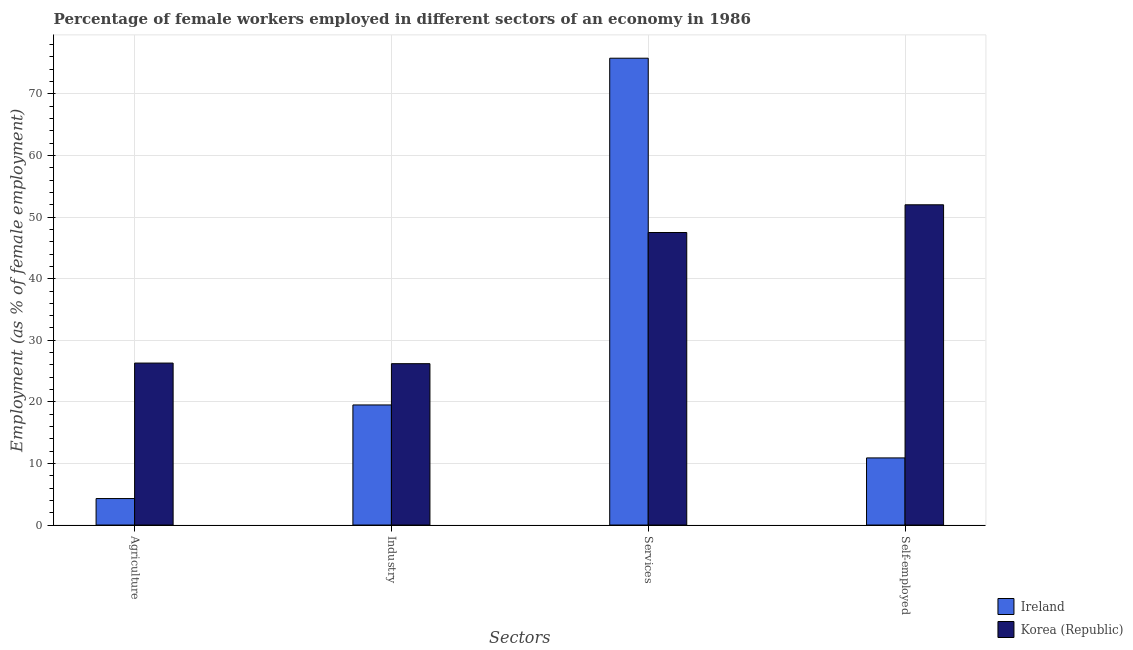Are the number of bars per tick equal to the number of legend labels?
Provide a short and direct response. Yes. Are the number of bars on each tick of the X-axis equal?
Your answer should be very brief. Yes. How many bars are there on the 4th tick from the right?
Your answer should be very brief. 2. What is the label of the 1st group of bars from the left?
Your answer should be compact. Agriculture. What is the percentage of self employed female workers in Ireland?
Your response must be concise. 10.9. Across all countries, what is the maximum percentage of female workers in services?
Give a very brief answer. 75.8. Across all countries, what is the minimum percentage of female workers in services?
Make the answer very short. 47.5. In which country was the percentage of female workers in services maximum?
Ensure brevity in your answer.  Ireland. In which country was the percentage of female workers in agriculture minimum?
Your response must be concise. Ireland. What is the total percentage of female workers in agriculture in the graph?
Your answer should be compact. 30.6. What is the difference between the percentage of female workers in services in Korea (Republic) and that in Ireland?
Offer a terse response. -28.3. What is the difference between the percentage of female workers in services in Ireland and the percentage of self employed female workers in Korea (Republic)?
Your answer should be compact. 23.8. What is the average percentage of self employed female workers per country?
Keep it short and to the point. 31.45. What is the difference between the percentage of female workers in industry and percentage of self employed female workers in Korea (Republic)?
Make the answer very short. -25.8. In how many countries, is the percentage of self employed female workers greater than 60 %?
Ensure brevity in your answer.  0. What is the ratio of the percentage of female workers in services in Ireland to that in Korea (Republic)?
Make the answer very short. 1.6. What is the difference between the highest and the second highest percentage of female workers in industry?
Offer a very short reply. 6.7. What is the difference between the highest and the lowest percentage of female workers in agriculture?
Your response must be concise. 22. In how many countries, is the percentage of female workers in services greater than the average percentage of female workers in services taken over all countries?
Offer a very short reply. 1. Is it the case that in every country, the sum of the percentage of female workers in industry and percentage of female workers in agriculture is greater than the sum of percentage of female workers in services and percentage of self employed female workers?
Make the answer very short. No. What does the 1st bar from the left in Agriculture represents?
Offer a terse response. Ireland. What does the 1st bar from the right in Self-employed represents?
Make the answer very short. Korea (Republic). Is it the case that in every country, the sum of the percentage of female workers in agriculture and percentage of female workers in industry is greater than the percentage of female workers in services?
Offer a very short reply. No. How many countries are there in the graph?
Provide a succinct answer. 2. What is the difference between two consecutive major ticks on the Y-axis?
Offer a very short reply. 10. Does the graph contain any zero values?
Keep it short and to the point. No. Does the graph contain grids?
Offer a very short reply. Yes. How many legend labels are there?
Offer a terse response. 2. What is the title of the graph?
Make the answer very short. Percentage of female workers employed in different sectors of an economy in 1986. What is the label or title of the X-axis?
Your answer should be compact. Sectors. What is the label or title of the Y-axis?
Give a very brief answer. Employment (as % of female employment). What is the Employment (as % of female employment) in Ireland in Agriculture?
Offer a very short reply. 4.3. What is the Employment (as % of female employment) in Korea (Republic) in Agriculture?
Your answer should be very brief. 26.3. What is the Employment (as % of female employment) of Ireland in Industry?
Keep it short and to the point. 19.5. What is the Employment (as % of female employment) in Korea (Republic) in Industry?
Offer a terse response. 26.2. What is the Employment (as % of female employment) of Ireland in Services?
Your answer should be compact. 75.8. What is the Employment (as % of female employment) in Korea (Republic) in Services?
Keep it short and to the point. 47.5. What is the Employment (as % of female employment) of Ireland in Self-employed?
Your answer should be very brief. 10.9. What is the Employment (as % of female employment) in Korea (Republic) in Self-employed?
Your answer should be compact. 52. Across all Sectors, what is the maximum Employment (as % of female employment) of Ireland?
Provide a short and direct response. 75.8. Across all Sectors, what is the maximum Employment (as % of female employment) of Korea (Republic)?
Your response must be concise. 52. Across all Sectors, what is the minimum Employment (as % of female employment) in Ireland?
Your response must be concise. 4.3. Across all Sectors, what is the minimum Employment (as % of female employment) of Korea (Republic)?
Offer a very short reply. 26.2. What is the total Employment (as % of female employment) in Ireland in the graph?
Provide a succinct answer. 110.5. What is the total Employment (as % of female employment) in Korea (Republic) in the graph?
Offer a terse response. 152. What is the difference between the Employment (as % of female employment) of Ireland in Agriculture and that in Industry?
Make the answer very short. -15.2. What is the difference between the Employment (as % of female employment) of Korea (Republic) in Agriculture and that in Industry?
Give a very brief answer. 0.1. What is the difference between the Employment (as % of female employment) of Ireland in Agriculture and that in Services?
Offer a terse response. -71.5. What is the difference between the Employment (as % of female employment) in Korea (Republic) in Agriculture and that in Services?
Your answer should be very brief. -21.2. What is the difference between the Employment (as % of female employment) of Ireland in Agriculture and that in Self-employed?
Give a very brief answer. -6.6. What is the difference between the Employment (as % of female employment) of Korea (Republic) in Agriculture and that in Self-employed?
Your response must be concise. -25.7. What is the difference between the Employment (as % of female employment) in Ireland in Industry and that in Services?
Provide a succinct answer. -56.3. What is the difference between the Employment (as % of female employment) of Korea (Republic) in Industry and that in Services?
Your response must be concise. -21.3. What is the difference between the Employment (as % of female employment) in Ireland in Industry and that in Self-employed?
Ensure brevity in your answer.  8.6. What is the difference between the Employment (as % of female employment) in Korea (Republic) in Industry and that in Self-employed?
Offer a very short reply. -25.8. What is the difference between the Employment (as % of female employment) in Ireland in Services and that in Self-employed?
Ensure brevity in your answer.  64.9. What is the difference between the Employment (as % of female employment) of Korea (Republic) in Services and that in Self-employed?
Your answer should be very brief. -4.5. What is the difference between the Employment (as % of female employment) of Ireland in Agriculture and the Employment (as % of female employment) of Korea (Republic) in Industry?
Offer a very short reply. -21.9. What is the difference between the Employment (as % of female employment) in Ireland in Agriculture and the Employment (as % of female employment) in Korea (Republic) in Services?
Provide a short and direct response. -43.2. What is the difference between the Employment (as % of female employment) in Ireland in Agriculture and the Employment (as % of female employment) in Korea (Republic) in Self-employed?
Provide a succinct answer. -47.7. What is the difference between the Employment (as % of female employment) of Ireland in Industry and the Employment (as % of female employment) of Korea (Republic) in Self-employed?
Give a very brief answer. -32.5. What is the difference between the Employment (as % of female employment) of Ireland in Services and the Employment (as % of female employment) of Korea (Republic) in Self-employed?
Keep it short and to the point. 23.8. What is the average Employment (as % of female employment) in Ireland per Sectors?
Provide a short and direct response. 27.62. What is the difference between the Employment (as % of female employment) in Ireland and Employment (as % of female employment) in Korea (Republic) in Agriculture?
Provide a succinct answer. -22. What is the difference between the Employment (as % of female employment) of Ireland and Employment (as % of female employment) of Korea (Republic) in Services?
Ensure brevity in your answer.  28.3. What is the difference between the Employment (as % of female employment) in Ireland and Employment (as % of female employment) in Korea (Republic) in Self-employed?
Offer a terse response. -41.1. What is the ratio of the Employment (as % of female employment) of Ireland in Agriculture to that in Industry?
Provide a succinct answer. 0.22. What is the ratio of the Employment (as % of female employment) of Korea (Republic) in Agriculture to that in Industry?
Provide a succinct answer. 1. What is the ratio of the Employment (as % of female employment) in Ireland in Agriculture to that in Services?
Your answer should be very brief. 0.06. What is the ratio of the Employment (as % of female employment) in Korea (Republic) in Agriculture to that in Services?
Ensure brevity in your answer.  0.55. What is the ratio of the Employment (as % of female employment) of Ireland in Agriculture to that in Self-employed?
Provide a short and direct response. 0.39. What is the ratio of the Employment (as % of female employment) in Korea (Republic) in Agriculture to that in Self-employed?
Your response must be concise. 0.51. What is the ratio of the Employment (as % of female employment) of Ireland in Industry to that in Services?
Offer a terse response. 0.26. What is the ratio of the Employment (as % of female employment) of Korea (Republic) in Industry to that in Services?
Your response must be concise. 0.55. What is the ratio of the Employment (as % of female employment) of Ireland in Industry to that in Self-employed?
Offer a terse response. 1.79. What is the ratio of the Employment (as % of female employment) in Korea (Republic) in Industry to that in Self-employed?
Offer a very short reply. 0.5. What is the ratio of the Employment (as % of female employment) in Ireland in Services to that in Self-employed?
Give a very brief answer. 6.95. What is the ratio of the Employment (as % of female employment) in Korea (Republic) in Services to that in Self-employed?
Make the answer very short. 0.91. What is the difference between the highest and the second highest Employment (as % of female employment) of Ireland?
Offer a terse response. 56.3. What is the difference between the highest and the lowest Employment (as % of female employment) in Ireland?
Give a very brief answer. 71.5. What is the difference between the highest and the lowest Employment (as % of female employment) of Korea (Republic)?
Offer a very short reply. 25.8. 